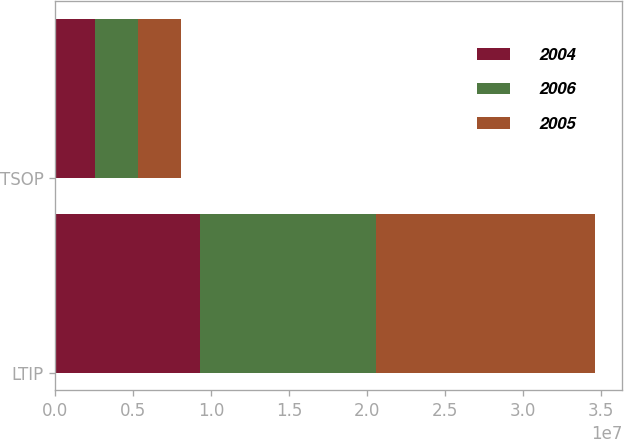Convert chart. <chart><loc_0><loc_0><loc_500><loc_500><stacked_bar_chart><ecel><fcel>LTIP<fcel>TSOP<nl><fcel>2004<fcel>9.28828e+06<fcel>2.5387e+06<nl><fcel>2006<fcel>1.13216e+07<fcel>2.7714e+06<nl><fcel>2005<fcel>1.40331e+07<fcel>2.7733e+06<nl></chart> 